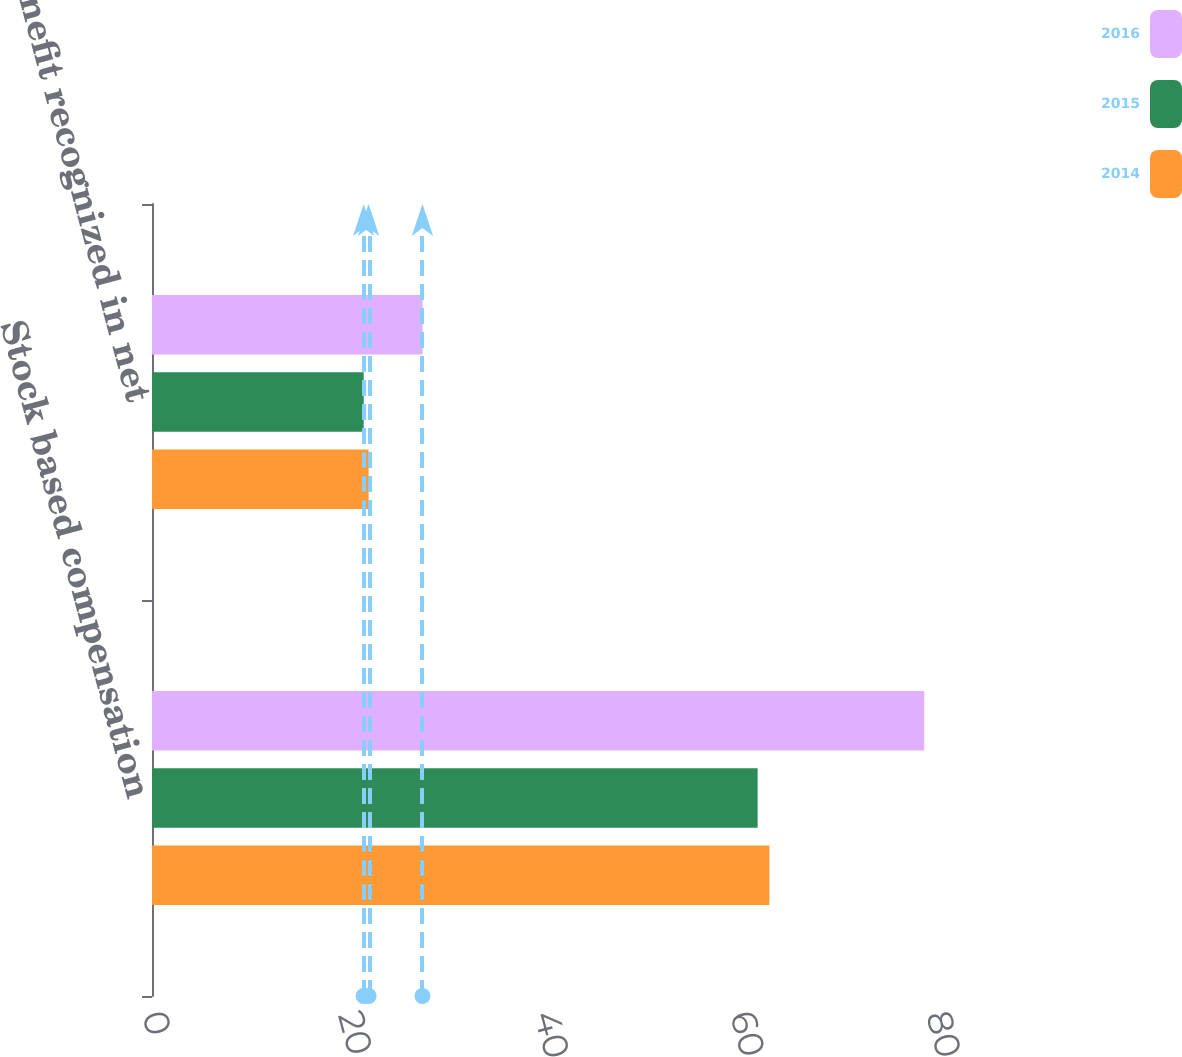Convert chart. <chart><loc_0><loc_0><loc_500><loc_500><stacked_bar_chart><ecel><fcel>Stock based compensation<fcel>Tax benefit recognized in net<nl><fcel>2016<fcel>78.8<fcel>27.6<nl><fcel>2015<fcel>61.8<fcel>21.6<nl><fcel>2014<fcel>63<fcel>22.1<nl></chart> 